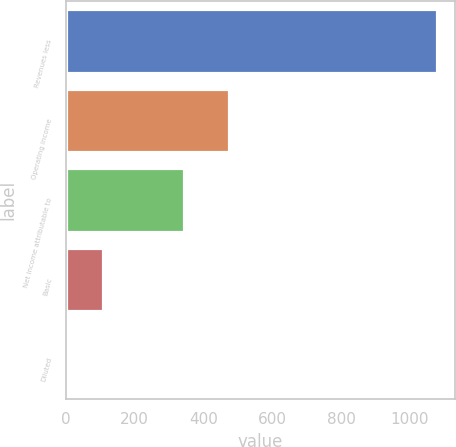<chart> <loc_0><loc_0><loc_500><loc_500><bar_chart><fcel>Revenues less<fcel>Operating income<fcel>Net income attributable to<fcel>Basic<fcel>Diluted<nl><fcel>1078<fcel>474<fcel>344<fcel>108.31<fcel>0.57<nl></chart> 